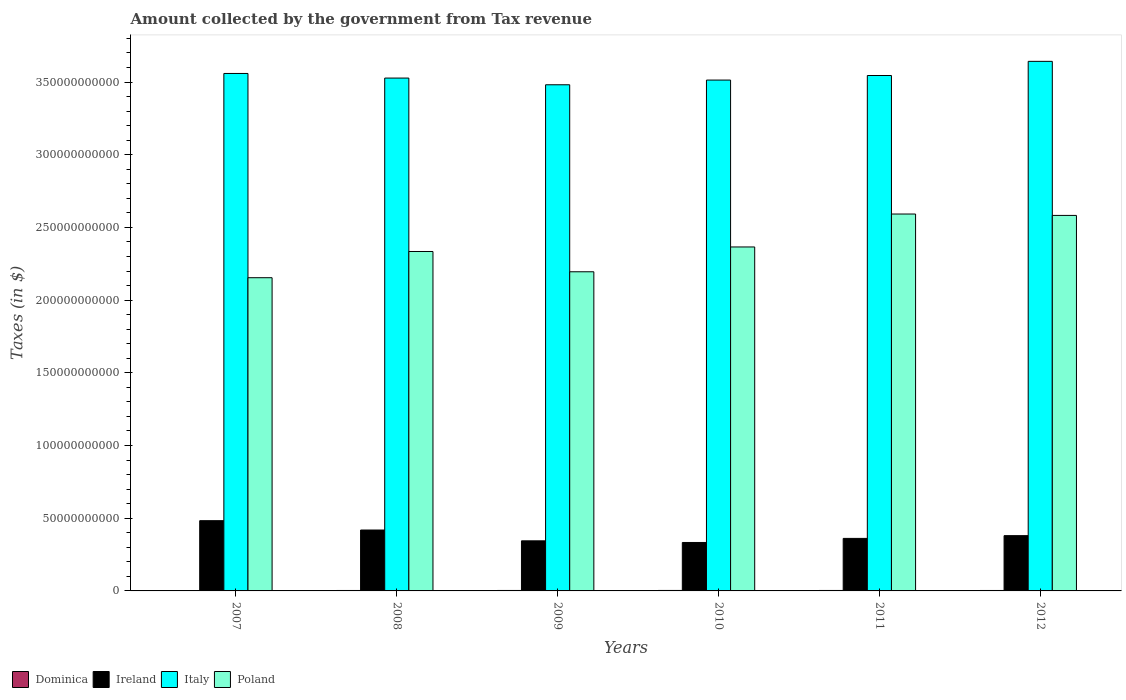How many different coloured bars are there?
Provide a short and direct response. 4. Are the number of bars per tick equal to the number of legend labels?
Ensure brevity in your answer.  Yes. Are the number of bars on each tick of the X-axis equal?
Keep it short and to the point. Yes. How many bars are there on the 2nd tick from the left?
Your answer should be compact. 4. How many bars are there on the 2nd tick from the right?
Keep it short and to the point. 4. What is the label of the 5th group of bars from the left?
Your answer should be compact. 2011. What is the amount collected by the government from tax revenue in Poland in 2008?
Your response must be concise. 2.33e+11. Across all years, what is the maximum amount collected by the government from tax revenue in Poland?
Provide a succinct answer. 2.59e+11. Across all years, what is the minimum amount collected by the government from tax revenue in Poland?
Your answer should be very brief. 2.15e+11. In which year was the amount collected by the government from tax revenue in Italy maximum?
Ensure brevity in your answer.  2012. What is the total amount collected by the government from tax revenue in Poland in the graph?
Your response must be concise. 1.42e+12. What is the difference between the amount collected by the government from tax revenue in Poland in 2009 and that in 2012?
Your response must be concise. -3.88e+1. What is the difference between the amount collected by the government from tax revenue in Poland in 2008 and the amount collected by the government from tax revenue in Ireland in 2011?
Your answer should be very brief. 1.97e+11. What is the average amount collected by the government from tax revenue in Italy per year?
Ensure brevity in your answer.  3.54e+11. In the year 2012, what is the difference between the amount collected by the government from tax revenue in Poland and amount collected by the government from tax revenue in Dominica?
Ensure brevity in your answer.  2.58e+11. What is the ratio of the amount collected by the government from tax revenue in Poland in 2007 to that in 2010?
Your answer should be very brief. 0.91. What is the difference between the highest and the second highest amount collected by the government from tax revenue in Dominica?
Your answer should be very brief. 7.30e+06. What is the difference between the highest and the lowest amount collected by the government from tax revenue in Ireland?
Ensure brevity in your answer.  1.50e+1. In how many years, is the amount collected by the government from tax revenue in Ireland greater than the average amount collected by the government from tax revenue in Ireland taken over all years?
Keep it short and to the point. 2. Is it the case that in every year, the sum of the amount collected by the government from tax revenue in Dominica and amount collected by the government from tax revenue in Poland is greater than the sum of amount collected by the government from tax revenue in Italy and amount collected by the government from tax revenue in Ireland?
Make the answer very short. Yes. What does the 2nd bar from the left in 2012 represents?
Offer a very short reply. Ireland. What does the 4th bar from the right in 2008 represents?
Your answer should be very brief. Dominica. Is it the case that in every year, the sum of the amount collected by the government from tax revenue in Ireland and amount collected by the government from tax revenue in Poland is greater than the amount collected by the government from tax revenue in Italy?
Provide a succinct answer. No. How many bars are there?
Your response must be concise. 24. How many years are there in the graph?
Your answer should be very brief. 6. What is the difference between two consecutive major ticks on the Y-axis?
Give a very brief answer. 5.00e+1. Are the values on the major ticks of Y-axis written in scientific E-notation?
Your response must be concise. No. Does the graph contain grids?
Provide a succinct answer. No. Where does the legend appear in the graph?
Provide a succinct answer. Bottom left. How many legend labels are there?
Give a very brief answer. 4. How are the legend labels stacked?
Your response must be concise. Horizontal. What is the title of the graph?
Your answer should be compact. Amount collected by the government from Tax revenue. Does "Fragile and conflict affected situations" appear as one of the legend labels in the graph?
Provide a succinct answer. No. What is the label or title of the Y-axis?
Offer a very short reply. Taxes (in $). What is the Taxes (in $) of Dominica in 2007?
Provide a succinct answer. 2.86e+08. What is the Taxes (in $) of Ireland in 2007?
Offer a very short reply. 4.83e+1. What is the Taxes (in $) of Italy in 2007?
Provide a succinct answer. 3.56e+11. What is the Taxes (in $) of Poland in 2007?
Provide a short and direct response. 2.15e+11. What is the Taxes (in $) of Dominica in 2008?
Make the answer very short. 3.07e+08. What is the Taxes (in $) of Ireland in 2008?
Your answer should be compact. 4.19e+1. What is the Taxes (in $) in Italy in 2008?
Make the answer very short. 3.53e+11. What is the Taxes (in $) of Poland in 2008?
Offer a terse response. 2.33e+11. What is the Taxes (in $) of Dominica in 2009?
Your answer should be compact. 3.21e+08. What is the Taxes (in $) of Ireland in 2009?
Offer a terse response. 3.45e+1. What is the Taxes (in $) of Italy in 2009?
Your response must be concise. 3.48e+11. What is the Taxes (in $) in Poland in 2009?
Your answer should be compact. 2.20e+11. What is the Taxes (in $) of Dominica in 2010?
Your answer should be compact. 3.28e+08. What is the Taxes (in $) in Ireland in 2010?
Ensure brevity in your answer.  3.33e+1. What is the Taxes (in $) of Italy in 2010?
Provide a succinct answer. 3.51e+11. What is the Taxes (in $) in Poland in 2010?
Make the answer very short. 2.37e+11. What is the Taxes (in $) in Dominica in 2011?
Your response must be concise. 3.12e+08. What is the Taxes (in $) of Ireland in 2011?
Provide a short and direct response. 3.61e+1. What is the Taxes (in $) in Italy in 2011?
Keep it short and to the point. 3.55e+11. What is the Taxes (in $) of Poland in 2011?
Your response must be concise. 2.59e+11. What is the Taxes (in $) of Dominica in 2012?
Provide a succinct answer. 3.03e+08. What is the Taxes (in $) in Ireland in 2012?
Give a very brief answer. 3.80e+1. What is the Taxes (in $) in Italy in 2012?
Offer a very short reply. 3.64e+11. What is the Taxes (in $) of Poland in 2012?
Offer a terse response. 2.58e+11. Across all years, what is the maximum Taxes (in $) of Dominica?
Your answer should be compact. 3.28e+08. Across all years, what is the maximum Taxes (in $) of Ireland?
Ensure brevity in your answer.  4.83e+1. Across all years, what is the maximum Taxes (in $) of Italy?
Provide a short and direct response. 3.64e+11. Across all years, what is the maximum Taxes (in $) of Poland?
Keep it short and to the point. 2.59e+11. Across all years, what is the minimum Taxes (in $) in Dominica?
Your response must be concise. 2.86e+08. Across all years, what is the minimum Taxes (in $) of Ireland?
Your answer should be very brief. 3.33e+1. Across all years, what is the minimum Taxes (in $) of Italy?
Ensure brevity in your answer.  3.48e+11. Across all years, what is the minimum Taxes (in $) in Poland?
Ensure brevity in your answer.  2.15e+11. What is the total Taxes (in $) in Dominica in the graph?
Make the answer very short. 1.86e+09. What is the total Taxes (in $) in Ireland in the graph?
Provide a succinct answer. 2.32e+11. What is the total Taxes (in $) in Italy in the graph?
Provide a succinct answer. 2.13e+12. What is the total Taxes (in $) in Poland in the graph?
Ensure brevity in your answer.  1.42e+12. What is the difference between the Taxes (in $) in Dominica in 2007 and that in 2008?
Ensure brevity in your answer.  -2.19e+07. What is the difference between the Taxes (in $) of Ireland in 2007 and that in 2008?
Offer a very short reply. 6.43e+09. What is the difference between the Taxes (in $) in Italy in 2007 and that in 2008?
Keep it short and to the point. 3.18e+09. What is the difference between the Taxes (in $) in Poland in 2007 and that in 2008?
Ensure brevity in your answer.  -1.80e+1. What is the difference between the Taxes (in $) in Dominica in 2007 and that in 2009?
Ensure brevity in your answer.  -3.51e+07. What is the difference between the Taxes (in $) in Ireland in 2007 and that in 2009?
Your response must be concise. 1.39e+1. What is the difference between the Taxes (in $) of Italy in 2007 and that in 2009?
Ensure brevity in your answer.  7.78e+09. What is the difference between the Taxes (in $) of Poland in 2007 and that in 2009?
Make the answer very short. -4.09e+09. What is the difference between the Taxes (in $) in Dominica in 2007 and that in 2010?
Keep it short and to the point. -4.24e+07. What is the difference between the Taxes (in $) in Ireland in 2007 and that in 2010?
Offer a very short reply. 1.50e+1. What is the difference between the Taxes (in $) in Italy in 2007 and that in 2010?
Offer a terse response. 4.54e+09. What is the difference between the Taxes (in $) of Poland in 2007 and that in 2010?
Give a very brief answer. -2.11e+1. What is the difference between the Taxes (in $) of Dominica in 2007 and that in 2011?
Offer a terse response. -2.64e+07. What is the difference between the Taxes (in $) of Ireland in 2007 and that in 2011?
Offer a terse response. 1.22e+1. What is the difference between the Taxes (in $) in Italy in 2007 and that in 2011?
Your answer should be compact. 1.41e+09. What is the difference between the Taxes (in $) of Poland in 2007 and that in 2011?
Your answer should be compact. -4.38e+1. What is the difference between the Taxes (in $) of Dominica in 2007 and that in 2012?
Provide a succinct answer. -1.72e+07. What is the difference between the Taxes (in $) in Ireland in 2007 and that in 2012?
Keep it short and to the point. 1.03e+1. What is the difference between the Taxes (in $) of Italy in 2007 and that in 2012?
Your response must be concise. -8.33e+09. What is the difference between the Taxes (in $) in Poland in 2007 and that in 2012?
Keep it short and to the point. -4.29e+1. What is the difference between the Taxes (in $) of Dominica in 2008 and that in 2009?
Provide a short and direct response. -1.32e+07. What is the difference between the Taxes (in $) of Ireland in 2008 and that in 2009?
Give a very brief answer. 7.44e+09. What is the difference between the Taxes (in $) of Italy in 2008 and that in 2009?
Offer a very short reply. 4.60e+09. What is the difference between the Taxes (in $) of Poland in 2008 and that in 2009?
Give a very brief answer. 1.40e+1. What is the difference between the Taxes (in $) of Dominica in 2008 and that in 2010?
Offer a very short reply. -2.05e+07. What is the difference between the Taxes (in $) in Ireland in 2008 and that in 2010?
Offer a very short reply. 8.56e+09. What is the difference between the Taxes (in $) in Italy in 2008 and that in 2010?
Give a very brief answer. 1.37e+09. What is the difference between the Taxes (in $) in Poland in 2008 and that in 2010?
Your response must be concise. -3.11e+09. What is the difference between the Taxes (in $) of Dominica in 2008 and that in 2011?
Make the answer very short. -4.50e+06. What is the difference between the Taxes (in $) in Ireland in 2008 and that in 2011?
Offer a terse response. 5.77e+09. What is the difference between the Taxes (in $) in Italy in 2008 and that in 2011?
Keep it short and to the point. -1.77e+09. What is the difference between the Taxes (in $) of Poland in 2008 and that in 2011?
Your answer should be compact. -2.58e+1. What is the difference between the Taxes (in $) in Dominica in 2008 and that in 2012?
Your response must be concise. 4.70e+06. What is the difference between the Taxes (in $) in Ireland in 2008 and that in 2012?
Keep it short and to the point. 3.87e+09. What is the difference between the Taxes (in $) of Italy in 2008 and that in 2012?
Provide a short and direct response. -1.15e+1. What is the difference between the Taxes (in $) of Poland in 2008 and that in 2012?
Your answer should be compact. -2.48e+1. What is the difference between the Taxes (in $) of Dominica in 2009 and that in 2010?
Provide a short and direct response. -7.30e+06. What is the difference between the Taxes (in $) of Ireland in 2009 and that in 2010?
Make the answer very short. 1.13e+09. What is the difference between the Taxes (in $) of Italy in 2009 and that in 2010?
Provide a short and direct response. -3.24e+09. What is the difference between the Taxes (in $) of Poland in 2009 and that in 2010?
Your answer should be compact. -1.71e+1. What is the difference between the Taxes (in $) in Dominica in 2009 and that in 2011?
Ensure brevity in your answer.  8.70e+06. What is the difference between the Taxes (in $) of Ireland in 2009 and that in 2011?
Provide a short and direct response. -1.67e+09. What is the difference between the Taxes (in $) in Italy in 2009 and that in 2011?
Provide a short and direct response. -6.37e+09. What is the difference between the Taxes (in $) in Poland in 2009 and that in 2011?
Provide a short and direct response. -3.97e+1. What is the difference between the Taxes (in $) in Dominica in 2009 and that in 2012?
Ensure brevity in your answer.  1.79e+07. What is the difference between the Taxes (in $) of Ireland in 2009 and that in 2012?
Offer a very short reply. -3.57e+09. What is the difference between the Taxes (in $) in Italy in 2009 and that in 2012?
Your response must be concise. -1.61e+1. What is the difference between the Taxes (in $) of Poland in 2009 and that in 2012?
Your answer should be compact. -3.88e+1. What is the difference between the Taxes (in $) in Dominica in 2010 and that in 2011?
Ensure brevity in your answer.  1.60e+07. What is the difference between the Taxes (in $) of Ireland in 2010 and that in 2011?
Offer a very short reply. -2.80e+09. What is the difference between the Taxes (in $) of Italy in 2010 and that in 2011?
Your response must be concise. -3.14e+09. What is the difference between the Taxes (in $) of Poland in 2010 and that in 2011?
Offer a terse response. -2.27e+1. What is the difference between the Taxes (in $) of Dominica in 2010 and that in 2012?
Your answer should be compact. 2.52e+07. What is the difference between the Taxes (in $) of Ireland in 2010 and that in 2012?
Make the answer very short. -4.69e+09. What is the difference between the Taxes (in $) in Italy in 2010 and that in 2012?
Keep it short and to the point. -1.29e+1. What is the difference between the Taxes (in $) of Poland in 2010 and that in 2012?
Your answer should be compact. -2.17e+1. What is the difference between the Taxes (in $) in Dominica in 2011 and that in 2012?
Your answer should be compact. 9.20e+06. What is the difference between the Taxes (in $) of Ireland in 2011 and that in 2012?
Provide a succinct answer. -1.89e+09. What is the difference between the Taxes (in $) in Italy in 2011 and that in 2012?
Provide a short and direct response. -9.73e+09. What is the difference between the Taxes (in $) of Poland in 2011 and that in 2012?
Give a very brief answer. 9.58e+08. What is the difference between the Taxes (in $) in Dominica in 2007 and the Taxes (in $) in Ireland in 2008?
Ensure brevity in your answer.  -4.16e+1. What is the difference between the Taxes (in $) of Dominica in 2007 and the Taxes (in $) of Italy in 2008?
Provide a short and direct response. -3.52e+11. What is the difference between the Taxes (in $) in Dominica in 2007 and the Taxes (in $) in Poland in 2008?
Offer a very short reply. -2.33e+11. What is the difference between the Taxes (in $) of Ireland in 2007 and the Taxes (in $) of Italy in 2008?
Keep it short and to the point. -3.04e+11. What is the difference between the Taxes (in $) in Ireland in 2007 and the Taxes (in $) in Poland in 2008?
Your answer should be compact. -1.85e+11. What is the difference between the Taxes (in $) of Italy in 2007 and the Taxes (in $) of Poland in 2008?
Your answer should be compact. 1.22e+11. What is the difference between the Taxes (in $) of Dominica in 2007 and the Taxes (in $) of Ireland in 2009?
Your response must be concise. -3.42e+1. What is the difference between the Taxes (in $) in Dominica in 2007 and the Taxes (in $) in Italy in 2009?
Provide a short and direct response. -3.48e+11. What is the difference between the Taxes (in $) in Dominica in 2007 and the Taxes (in $) in Poland in 2009?
Offer a terse response. -2.19e+11. What is the difference between the Taxes (in $) of Ireland in 2007 and the Taxes (in $) of Italy in 2009?
Provide a succinct answer. -3.00e+11. What is the difference between the Taxes (in $) of Ireland in 2007 and the Taxes (in $) of Poland in 2009?
Provide a short and direct response. -1.71e+11. What is the difference between the Taxes (in $) of Italy in 2007 and the Taxes (in $) of Poland in 2009?
Keep it short and to the point. 1.36e+11. What is the difference between the Taxes (in $) in Dominica in 2007 and the Taxes (in $) in Ireland in 2010?
Give a very brief answer. -3.30e+1. What is the difference between the Taxes (in $) of Dominica in 2007 and the Taxes (in $) of Italy in 2010?
Your answer should be compact. -3.51e+11. What is the difference between the Taxes (in $) of Dominica in 2007 and the Taxes (in $) of Poland in 2010?
Your response must be concise. -2.36e+11. What is the difference between the Taxes (in $) in Ireland in 2007 and the Taxes (in $) in Italy in 2010?
Ensure brevity in your answer.  -3.03e+11. What is the difference between the Taxes (in $) in Ireland in 2007 and the Taxes (in $) in Poland in 2010?
Ensure brevity in your answer.  -1.88e+11. What is the difference between the Taxes (in $) in Italy in 2007 and the Taxes (in $) in Poland in 2010?
Provide a succinct answer. 1.19e+11. What is the difference between the Taxes (in $) in Dominica in 2007 and the Taxes (in $) in Ireland in 2011?
Your answer should be very brief. -3.58e+1. What is the difference between the Taxes (in $) of Dominica in 2007 and the Taxes (in $) of Italy in 2011?
Your answer should be very brief. -3.54e+11. What is the difference between the Taxes (in $) in Dominica in 2007 and the Taxes (in $) in Poland in 2011?
Keep it short and to the point. -2.59e+11. What is the difference between the Taxes (in $) in Ireland in 2007 and the Taxes (in $) in Italy in 2011?
Provide a succinct answer. -3.06e+11. What is the difference between the Taxes (in $) in Ireland in 2007 and the Taxes (in $) in Poland in 2011?
Provide a short and direct response. -2.11e+11. What is the difference between the Taxes (in $) of Italy in 2007 and the Taxes (in $) of Poland in 2011?
Ensure brevity in your answer.  9.67e+1. What is the difference between the Taxes (in $) of Dominica in 2007 and the Taxes (in $) of Ireland in 2012?
Your answer should be compact. -3.77e+1. What is the difference between the Taxes (in $) of Dominica in 2007 and the Taxes (in $) of Italy in 2012?
Offer a terse response. -3.64e+11. What is the difference between the Taxes (in $) of Dominica in 2007 and the Taxes (in $) of Poland in 2012?
Keep it short and to the point. -2.58e+11. What is the difference between the Taxes (in $) in Ireland in 2007 and the Taxes (in $) in Italy in 2012?
Give a very brief answer. -3.16e+11. What is the difference between the Taxes (in $) in Ireland in 2007 and the Taxes (in $) in Poland in 2012?
Give a very brief answer. -2.10e+11. What is the difference between the Taxes (in $) in Italy in 2007 and the Taxes (in $) in Poland in 2012?
Provide a short and direct response. 9.76e+1. What is the difference between the Taxes (in $) of Dominica in 2008 and the Taxes (in $) of Ireland in 2009?
Give a very brief answer. -3.41e+1. What is the difference between the Taxes (in $) of Dominica in 2008 and the Taxes (in $) of Italy in 2009?
Offer a very short reply. -3.48e+11. What is the difference between the Taxes (in $) of Dominica in 2008 and the Taxes (in $) of Poland in 2009?
Keep it short and to the point. -2.19e+11. What is the difference between the Taxes (in $) in Ireland in 2008 and the Taxes (in $) in Italy in 2009?
Make the answer very short. -3.06e+11. What is the difference between the Taxes (in $) of Ireland in 2008 and the Taxes (in $) of Poland in 2009?
Your answer should be very brief. -1.78e+11. What is the difference between the Taxes (in $) in Italy in 2008 and the Taxes (in $) in Poland in 2009?
Keep it short and to the point. 1.33e+11. What is the difference between the Taxes (in $) of Dominica in 2008 and the Taxes (in $) of Ireland in 2010?
Keep it short and to the point. -3.30e+1. What is the difference between the Taxes (in $) in Dominica in 2008 and the Taxes (in $) in Italy in 2010?
Provide a short and direct response. -3.51e+11. What is the difference between the Taxes (in $) in Dominica in 2008 and the Taxes (in $) in Poland in 2010?
Provide a succinct answer. -2.36e+11. What is the difference between the Taxes (in $) of Ireland in 2008 and the Taxes (in $) of Italy in 2010?
Keep it short and to the point. -3.09e+11. What is the difference between the Taxes (in $) in Ireland in 2008 and the Taxes (in $) in Poland in 2010?
Offer a very short reply. -1.95e+11. What is the difference between the Taxes (in $) in Italy in 2008 and the Taxes (in $) in Poland in 2010?
Keep it short and to the point. 1.16e+11. What is the difference between the Taxes (in $) in Dominica in 2008 and the Taxes (in $) in Ireland in 2011?
Provide a short and direct response. -3.58e+1. What is the difference between the Taxes (in $) of Dominica in 2008 and the Taxes (in $) of Italy in 2011?
Give a very brief answer. -3.54e+11. What is the difference between the Taxes (in $) of Dominica in 2008 and the Taxes (in $) of Poland in 2011?
Your response must be concise. -2.59e+11. What is the difference between the Taxes (in $) of Ireland in 2008 and the Taxes (in $) of Italy in 2011?
Offer a terse response. -3.13e+11. What is the difference between the Taxes (in $) in Ireland in 2008 and the Taxes (in $) in Poland in 2011?
Your response must be concise. -2.17e+11. What is the difference between the Taxes (in $) in Italy in 2008 and the Taxes (in $) in Poland in 2011?
Provide a short and direct response. 9.35e+1. What is the difference between the Taxes (in $) in Dominica in 2008 and the Taxes (in $) in Ireland in 2012?
Your answer should be compact. -3.77e+1. What is the difference between the Taxes (in $) of Dominica in 2008 and the Taxes (in $) of Italy in 2012?
Your response must be concise. -3.64e+11. What is the difference between the Taxes (in $) in Dominica in 2008 and the Taxes (in $) in Poland in 2012?
Provide a short and direct response. -2.58e+11. What is the difference between the Taxes (in $) of Ireland in 2008 and the Taxes (in $) of Italy in 2012?
Offer a very short reply. -3.22e+11. What is the difference between the Taxes (in $) in Ireland in 2008 and the Taxes (in $) in Poland in 2012?
Provide a succinct answer. -2.16e+11. What is the difference between the Taxes (in $) of Italy in 2008 and the Taxes (in $) of Poland in 2012?
Offer a terse response. 9.45e+1. What is the difference between the Taxes (in $) of Dominica in 2009 and the Taxes (in $) of Ireland in 2010?
Provide a short and direct response. -3.30e+1. What is the difference between the Taxes (in $) in Dominica in 2009 and the Taxes (in $) in Italy in 2010?
Your answer should be very brief. -3.51e+11. What is the difference between the Taxes (in $) in Dominica in 2009 and the Taxes (in $) in Poland in 2010?
Make the answer very short. -2.36e+11. What is the difference between the Taxes (in $) in Ireland in 2009 and the Taxes (in $) in Italy in 2010?
Keep it short and to the point. -3.17e+11. What is the difference between the Taxes (in $) of Ireland in 2009 and the Taxes (in $) of Poland in 2010?
Your response must be concise. -2.02e+11. What is the difference between the Taxes (in $) of Italy in 2009 and the Taxes (in $) of Poland in 2010?
Make the answer very short. 1.12e+11. What is the difference between the Taxes (in $) in Dominica in 2009 and the Taxes (in $) in Ireland in 2011?
Your response must be concise. -3.58e+1. What is the difference between the Taxes (in $) in Dominica in 2009 and the Taxes (in $) in Italy in 2011?
Provide a short and direct response. -3.54e+11. What is the difference between the Taxes (in $) of Dominica in 2009 and the Taxes (in $) of Poland in 2011?
Ensure brevity in your answer.  -2.59e+11. What is the difference between the Taxes (in $) in Ireland in 2009 and the Taxes (in $) in Italy in 2011?
Keep it short and to the point. -3.20e+11. What is the difference between the Taxes (in $) in Ireland in 2009 and the Taxes (in $) in Poland in 2011?
Your response must be concise. -2.25e+11. What is the difference between the Taxes (in $) of Italy in 2009 and the Taxes (in $) of Poland in 2011?
Your answer should be compact. 8.89e+1. What is the difference between the Taxes (in $) in Dominica in 2009 and the Taxes (in $) in Ireland in 2012?
Offer a very short reply. -3.77e+1. What is the difference between the Taxes (in $) in Dominica in 2009 and the Taxes (in $) in Italy in 2012?
Offer a very short reply. -3.64e+11. What is the difference between the Taxes (in $) in Dominica in 2009 and the Taxes (in $) in Poland in 2012?
Offer a very short reply. -2.58e+11. What is the difference between the Taxes (in $) in Ireland in 2009 and the Taxes (in $) in Italy in 2012?
Give a very brief answer. -3.30e+11. What is the difference between the Taxes (in $) in Ireland in 2009 and the Taxes (in $) in Poland in 2012?
Your answer should be very brief. -2.24e+11. What is the difference between the Taxes (in $) of Italy in 2009 and the Taxes (in $) of Poland in 2012?
Offer a terse response. 8.99e+1. What is the difference between the Taxes (in $) of Dominica in 2010 and the Taxes (in $) of Ireland in 2011?
Ensure brevity in your answer.  -3.58e+1. What is the difference between the Taxes (in $) of Dominica in 2010 and the Taxes (in $) of Italy in 2011?
Provide a succinct answer. -3.54e+11. What is the difference between the Taxes (in $) in Dominica in 2010 and the Taxes (in $) in Poland in 2011?
Make the answer very short. -2.59e+11. What is the difference between the Taxes (in $) of Ireland in 2010 and the Taxes (in $) of Italy in 2011?
Your response must be concise. -3.21e+11. What is the difference between the Taxes (in $) in Ireland in 2010 and the Taxes (in $) in Poland in 2011?
Keep it short and to the point. -2.26e+11. What is the difference between the Taxes (in $) in Italy in 2010 and the Taxes (in $) in Poland in 2011?
Your answer should be compact. 9.21e+1. What is the difference between the Taxes (in $) of Dominica in 2010 and the Taxes (in $) of Ireland in 2012?
Ensure brevity in your answer.  -3.77e+1. What is the difference between the Taxes (in $) in Dominica in 2010 and the Taxes (in $) in Italy in 2012?
Offer a terse response. -3.64e+11. What is the difference between the Taxes (in $) of Dominica in 2010 and the Taxes (in $) of Poland in 2012?
Offer a terse response. -2.58e+11. What is the difference between the Taxes (in $) in Ireland in 2010 and the Taxes (in $) in Italy in 2012?
Provide a short and direct response. -3.31e+11. What is the difference between the Taxes (in $) in Ireland in 2010 and the Taxes (in $) in Poland in 2012?
Your answer should be compact. -2.25e+11. What is the difference between the Taxes (in $) of Italy in 2010 and the Taxes (in $) of Poland in 2012?
Make the answer very short. 9.31e+1. What is the difference between the Taxes (in $) in Dominica in 2011 and the Taxes (in $) in Ireland in 2012?
Keep it short and to the point. -3.77e+1. What is the difference between the Taxes (in $) of Dominica in 2011 and the Taxes (in $) of Italy in 2012?
Your response must be concise. -3.64e+11. What is the difference between the Taxes (in $) of Dominica in 2011 and the Taxes (in $) of Poland in 2012?
Give a very brief answer. -2.58e+11. What is the difference between the Taxes (in $) in Ireland in 2011 and the Taxes (in $) in Italy in 2012?
Your answer should be compact. -3.28e+11. What is the difference between the Taxes (in $) of Ireland in 2011 and the Taxes (in $) of Poland in 2012?
Give a very brief answer. -2.22e+11. What is the difference between the Taxes (in $) in Italy in 2011 and the Taxes (in $) in Poland in 2012?
Your answer should be very brief. 9.62e+1. What is the average Taxes (in $) of Dominica per year?
Make the answer very short. 3.09e+08. What is the average Taxes (in $) of Ireland per year?
Offer a terse response. 3.87e+1. What is the average Taxes (in $) of Italy per year?
Your answer should be very brief. 3.54e+11. What is the average Taxes (in $) in Poland per year?
Your answer should be compact. 2.37e+11. In the year 2007, what is the difference between the Taxes (in $) in Dominica and Taxes (in $) in Ireland?
Make the answer very short. -4.80e+1. In the year 2007, what is the difference between the Taxes (in $) in Dominica and Taxes (in $) in Italy?
Give a very brief answer. -3.56e+11. In the year 2007, what is the difference between the Taxes (in $) in Dominica and Taxes (in $) in Poland?
Ensure brevity in your answer.  -2.15e+11. In the year 2007, what is the difference between the Taxes (in $) of Ireland and Taxes (in $) of Italy?
Provide a short and direct response. -3.08e+11. In the year 2007, what is the difference between the Taxes (in $) in Ireland and Taxes (in $) in Poland?
Make the answer very short. -1.67e+11. In the year 2007, what is the difference between the Taxes (in $) of Italy and Taxes (in $) of Poland?
Give a very brief answer. 1.40e+11. In the year 2008, what is the difference between the Taxes (in $) of Dominica and Taxes (in $) of Ireland?
Provide a short and direct response. -4.16e+1. In the year 2008, what is the difference between the Taxes (in $) in Dominica and Taxes (in $) in Italy?
Make the answer very short. -3.52e+11. In the year 2008, what is the difference between the Taxes (in $) in Dominica and Taxes (in $) in Poland?
Keep it short and to the point. -2.33e+11. In the year 2008, what is the difference between the Taxes (in $) in Ireland and Taxes (in $) in Italy?
Ensure brevity in your answer.  -3.11e+11. In the year 2008, what is the difference between the Taxes (in $) in Ireland and Taxes (in $) in Poland?
Your answer should be very brief. -1.92e+11. In the year 2008, what is the difference between the Taxes (in $) of Italy and Taxes (in $) of Poland?
Provide a short and direct response. 1.19e+11. In the year 2009, what is the difference between the Taxes (in $) in Dominica and Taxes (in $) in Ireland?
Make the answer very short. -3.41e+1. In the year 2009, what is the difference between the Taxes (in $) in Dominica and Taxes (in $) in Italy?
Your answer should be very brief. -3.48e+11. In the year 2009, what is the difference between the Taxes (in $) of Dominica and Taxes (in $) of Poland?
Offer a terse response. -2.19e+11. In the year 2009, what is the difference between the Taxes (in $) in Ireland and Taxes (in $) in Italy?
Keep it short and to the point. -3.14e+11. In the year 2009, what is the difference between the Taxes (in $) in Ireland and Taxes (in $) in Poland?
Make the answer very short. -1.85e+11. In the year 2009, what is the difference between the Taxes (in $) of Italy and Taxes (in $) of Poland?
Provide a succinct answer. 1.29e+11. In the year 2010, what is the difference between the Taxes (in $) of Dominica and Taxes (in $) of Ireland?
Your answer should be compact. -3.30e+1. In the year 2010, what is the difference between the Taxes (in $) of Dominica and Taxes (in $) of Italy?
Offer a terse response. -3.51e+11. In the year 2010, what is the difference between the Taxes (in $) of Dominica and Taxes (in $) of Poland?
Offer a terse response. -2.36e+11. In the year 2010, what is the difference between the Taxes (in $) in Ireland and Taxes (in $) in Italy?
Ensure brevity in your answer.  -3.18e+11. In the year 2010, what is the difference between the Taxes (in $) in Ireland and Taxes (in $) in Poland?
Your response must be concise. -2.03e+11. In the year 2010, what is the difference between the Taxes (in $) of Italy and Taxes (in $) of Poland?
Your answer should be compact. 1.15e+11. In the year 2011, what is the difference between the Taxes (in $) in Dominica and Taxes (in $) in Ireland?
Your response must be concise. -3.58e+1. In the year 2011, what is the difference between the Taxes (in $) of Dominica and Taxes (in $) of Italy?
Your answer should be very brief. -3.54e+11. In the year 2011, what is the difference between the Taxes (in $) of Dominica and Taxes (in $) of Poland?
Give a very brief answer. -2.59e+11. In the year 2011, what is the difference between the Taxes (in $) in Ireland and Taxes (in $) in Italy?
Your answer should be very brief. -3.18e+11. In the year 2011, what is the difference between the Taxes (in $) of Ireland and Taxes (in $) of Poland?
Make the answer very short. -2.23e+11. In the year 2011, what is the difference between the Taxes (in $) in Italy and Taxes (in $) in Poland?
Your response must be concise. 9.53e+1. In the year 2012, what is the difference between the Taxes (in $) in Dominica and Taxes (in $) in Ireland?
Your answer should be compact. -3.77e+1. In the year 2012, what is the difference between the Taxes (in $) of Dominica and Taxes (in $) of Italy?
Offer a very short reply. -3.64e+11. In the year 2012, what is the difference between the Taxes (in $) of Dominica and Taxes (in $) of Poland?
Your answer should be compact. -2.58e+11. In the year 2012, what is the difference between the Taxes (in $) in Ireland and Taxes (in $) in Italy?
Provide a succinct answer. -3.26e+11. In the year 2012, what is the difference between the Taxes (in $) in Ireland and Taxes (in $) in Poland?
Your answer should be compact. -2.20e+11. In the year 2012, what is the difference between the Taxes (in $) of Italy and Taxes (in $) of Poland?
Give a very brief answer. 1.06e+11. What is the ratio of the Taxes (in $) of Dominica in 2007 to that in 2008?
Make the answer very short. 0.93. What is the ratio of the Taxes (in $) in Ireland in 2007 to that in 2008?
Your answer should be compact. 1.15. What is the ratio of the Taxes (in $) of Italy in 2007 to that in 2008?
Provide a succinct answer. 1.01. What is the ratio of the Taxes (in $) in Poland in 2007 to that in 2008?
Offer a very short reply. 0.92. What is the ratio of the Taxes (in $) in Dominica in 2007 to that in 2009?
Your answer should be very brief. 0.89. What is the ratio of the Taxes (in $) of Ireland in 2007 to that in 2009?
Make the answer very short. 1.4. What is the ratio of the Taxes (in $) of Italy in 2007 to that in 2009?
Offer a very short reply. 1.02. What is the ratio of the Taxes (in $) of Poland in 2007 to that in 2009?
Your answer should be compact. 0.98. What is the ratio of the Taxes (in $) in Dominica in 2007 to that in 2010?
Your response must be concise. 0.87. What is the ratio of the Taxes (in $) in Ireland in 2007 to that in 2010?
Ensure brevity in your answer.  1.45. What is the ratio of the Taxes (in $) in Italy in 2007 to that in 2010?
Offer a terse response. 1.01. What is the ratio of the Taxes (in $) in Poland in 2007 to that in 2010?
Provide a succinct answer. 0.91. What is the ratio of the Taxes (in $) in Dominica in 2007 to that in 2011?
Make the answer very short. 0.92. What is the ratio of the Taxes (in $) of Ireland in 2007 to that in 2011?
Give a very brief answer. 1.34. What is the ratio of the Taxes (in $) of Italy in 2007 to that in 2011?
Keep it short and to the point. 1. What is the ratio of the Taxes (in $) of Poland in 2007 to that in 2011?
Provide a succinct answer. 0.83. What is the ratio of the Taxes (in $) of Dominica in 2007 to that in 2012?
Give a very brief answer. 0.94. What is the ratio of the Taxes (in $) of Ireland in 2007 to that in 2012?
Ensure brevity in your answer.  1.27. What is the ratio of the Taxes (in $) in Italy in 2007 to that in 2012?
Offer a terse response. 0.98. What is the ratio of the Taxes (in $) in Poland in 2007 to that in 2012?
Your answer should be very brief. 0.83. What is the ratio of the Taxes (in $) in Dominica in 2008 to that in 2009?
Provide a short and direct response. 0.96. What is the ratio of the Taxes (in $) of Ireland in 2008 to that in 2009?
Ensure brevity in your answer.  1.22. What is the ratio of the Taxes (in $) in Italy in 2008 to that in 2009?
Your response must be concise. 1.01. What is the ratio of the Taxes (in $) in Poland in 2008 to that in 2009?
Keep it short and to the point. 1.06. What is the ratio of the Taxes (in $) in Ireland in 2008 to that in 2010?
Keep it short and to the point. 1.26. What is the ratio of the Taxes (in $) of Italy in 2008 to that in 2010?
Keep it short and to the point. 1. What is the ratio of the Taxes (in $) of Dominica in 2008 to that in 2011?
Give a very brief answer. 0.99. What is the ratio of the Taxes (in $) in Ireland in 2008 to that in 2011?
Offer a terse response. 1.16. What is the ratio of the Taxes (in $) in Poland in 2008 to that in 2011?
Provide a short and direct response. 0.9. What is the ratio of the Taxes (in $) in Dominica in 2008 to that in 2012?
Your answer should be very brief. 1.02. What is the ratio of the Taxes (in $) of Ireland in 2008 to that in 2012?
Give a very brief answer. 1.1. What is the ratio of the Taxes (in $) in Italy in 2008 to that in 2012?
Make the answer very short. 0.97. What is the ratio of the Taxes (in $) in Poland in 2008 to that in 2012?
Give a very brief answer. 0.9. What is the ratio of the Taxes (in $) in Dominica in 2009 to that in 2010?
Ensure brevity in your answer.  0.98. What is the ratio of the Taxes (in $) of Ireland in 2009 to that in 2010?
Provide a short and direct response. 1.03. What is the ratio of the Taxes (in $) in Italy in 2009 to that in 2010?
Offer a very short reply. 0.99. What is the ratio of the Taxes (in $) in Poland in 2009 to that in 2010?
Your answer should be compact. 0.93. What is the ratio of the Taxes (in $) of Dominica in 2009 to that in 2011?
Ensure brevity in your answer.  1.03. What is the ratio of the Taxes (in $) in Ireland in 2009 to that in 2011?
Ensure brevity in your answer.  0.95. What is the ratio of the Taxes (in $) in Poland in 2009 to that in 2011?
Ensure brevity in your answer.  0.85. What is the ratio of the Taxes (in $) in Dominica in 2009 to that in 2012?
Give a very brief answer. 1.06. What is the ratio of the Taxes (in $) in Ireland in 2009 to that in 2012?
Offer a very short reply. 0.91. What is the ratio of the Taxes (in $) of Italy in 2009 to that in 2012?
Ensure brevity in your answer.  0.96. What is the ratio of the Taxes (in $) in Poland in 2009 to that in 2012?
Offer a very short reply. 0.85. What is the ratio of the Taxes (in $) of Dominica in 2010 to that in 2011?
Make the answer very short. 1.05. What is the ratio of the Taxes (in $) of Ireland in 2010 to that in 2011?
Provide a short and direct response. 0.92. What is the ratio of the Taxes (in $) in Italy in 2010 to that in 2011?
Provide a succinct answer. 0.99. What is the ratio of the Taxes (in $) in Poland in 2010 to that in 2011?
Provide a short and direct response. 0.91. What is the ratio of the Taxes (in $) in Dominica in 2010 to that in 2012?
Your answer should be very brief. 1.08. What is the ratio of the Taxes (in $) of Ireland in 2010 to that in 2012?
Your answer should be very brief. 0.88. What is the ratio of the Taxes (in $) in Italy in 2010 to that in 2012?
Offer a terse response. 0.96. What is the ratio of the Taxes (in $) in Poland in 2010 to that in 2012?
Keep it short and to the point. 0.92. What is the ratio of the Taxes (in $) in Dominica in 2011 to that in 2012?
Your answer should be compact. 1.03. What is the ratio of the Taxes (in $) of Ireland in 2011 to that in 2012?
Your answer should be compact. 0.95. What is the ratio of the Taxes (in $) in Italy in 2011 to that in 2012?
Your response must be concise. 0.97. What is the difference between the highest and the second highest Taxes (in $) in Dominica?
Offer a very short reply. 7.30e+06. What is the difference between the highest and the second highest Taxes (in $) of Ireland?
Your answer should be compact. 6.43e+09. What is the difference between the highest and the second highest Taxes (in $) in Italy?
Provide a short and direct response. 8.33e+09. What is the difference between the highest and the second highest Taxes (in $) in Poland?
Provide a short and direct response. 9.58e+08. What is the difference between the highest and the lowest Taxes (in $) in Dominica?
Provide a short and direct response. 4.24e+07. What is the difference between the highest and the lowest Taxes (in $) in Ireland?
Your answer should be very brief. 1.50e+1. What is the difference between the highest and the lowest Taxes (in $) of Italy?
Provide a short and direct response. 1.61e+1. What is the difference between the highest and the lowest Taxes (in $) of Poland?
Ensure brevity in your answer.  4.38e+1. 